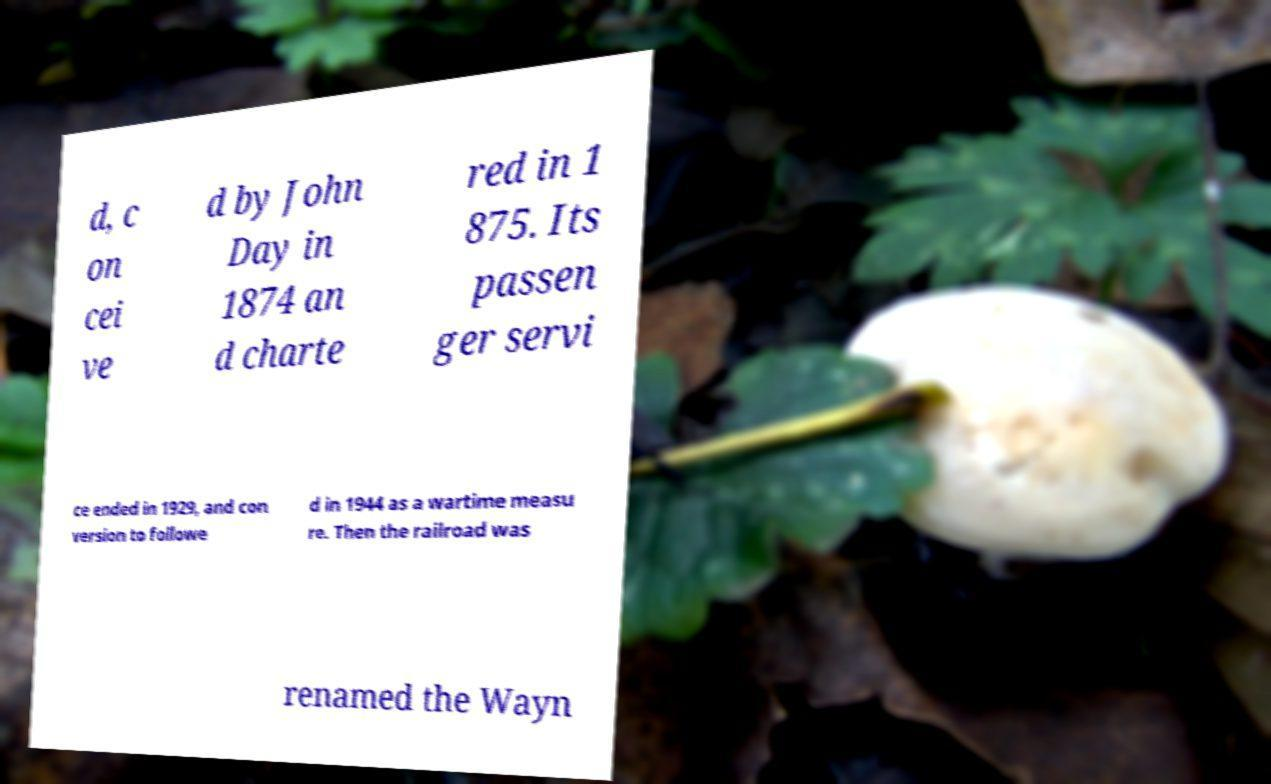Please identify and transcribe the text found in this image. d, c on cei ve d by John Day in 1874 an d charte red in 1 875. Its passen ger servi ce ended in 1929, and con version to followe d in 1944 as a wartime measu re. Then the railroad was renamed the Wayn 